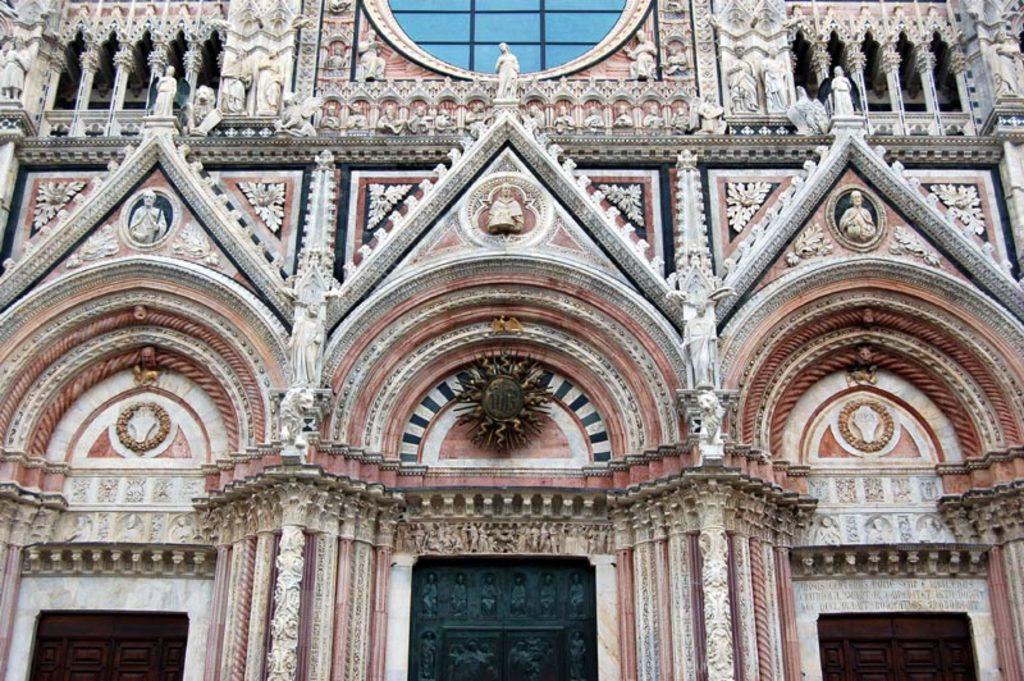How would you summarize this image in a sentence or two? In this picture there is a building. At the top i can see the statues near to the window. At the bottom i can see the doors. Above that there is some object which is hanging from the wall. 